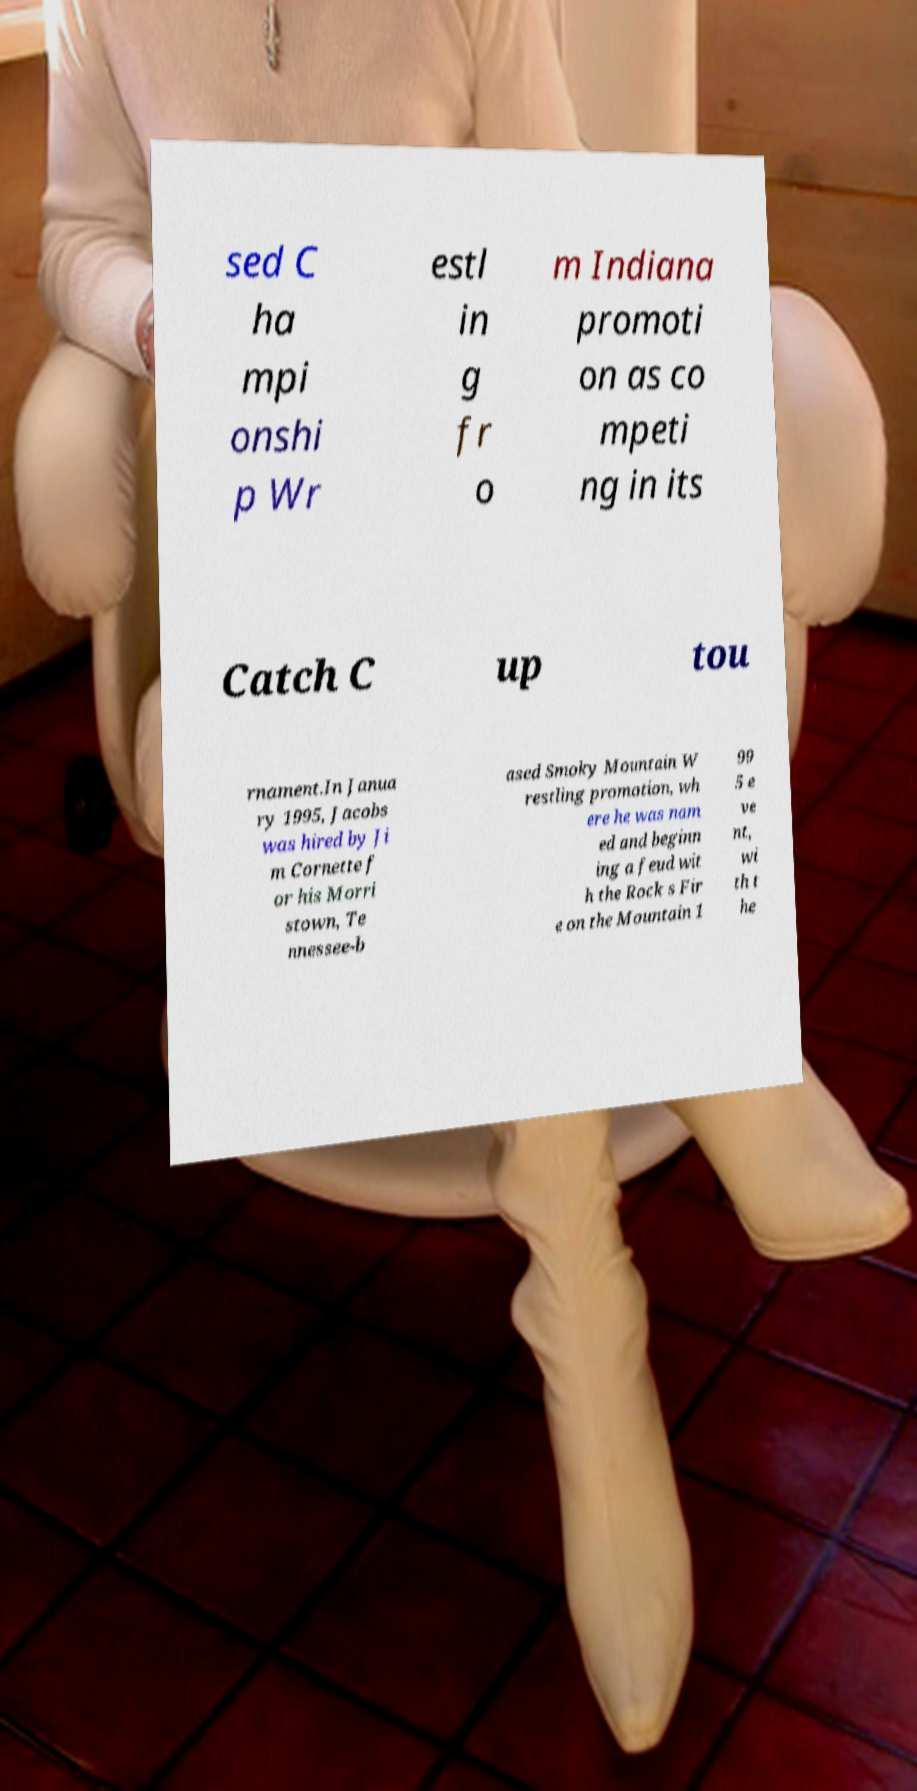Could you extract and type out the text from this image? sed C ha mpi onshi p Wr estl in g fr o m Indiana promoti on as co mpeti ng in its Catch C up tou rnament.In Janua ry 1995, Jacobs was hired by Ji m Cornette f or his Morri stown, Te nnessee-b ased Smoky Mountain W restling promotion, wh ere he was nam ed and beginn ing a feud wit h the Rock s Fir e on the Mountain 1 99 5 e ve nt, wi th t he 